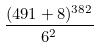Convert formula to latex. <formula><loc_0><loc_0><loc_500><loc_500>\frac { ( 4 9 1 + 8 ) ^ { 3 8 2 } } { 6 ^ { 2 } }</formula> 